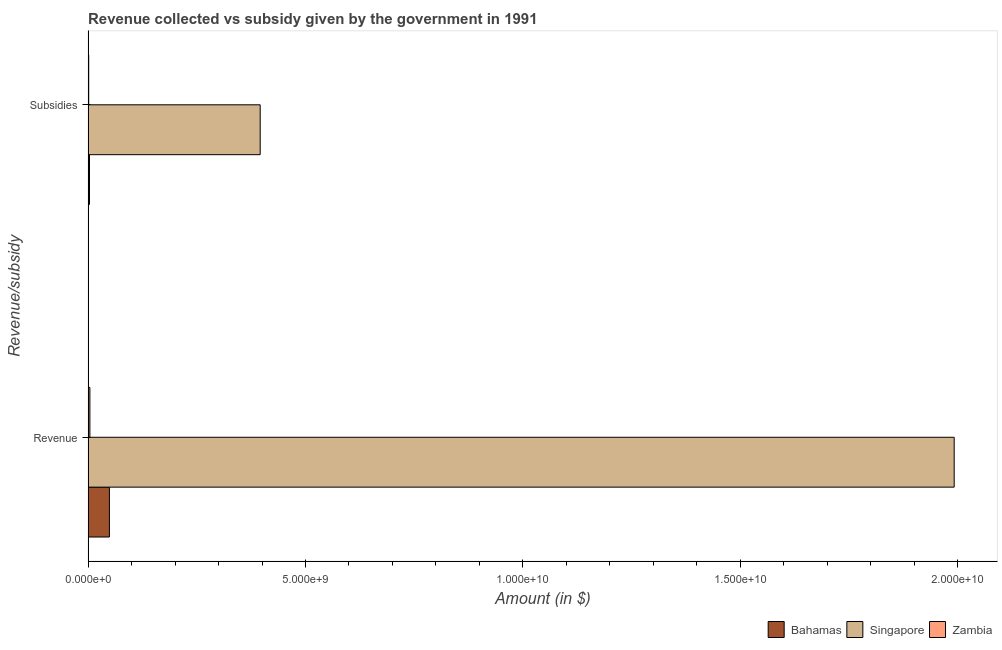How many different coloured bars are there?
Provide a short and direct response. 3. How many groups of bars are there?
Keep it short and to the point. 2. Are the number of bars on each tick of the Y-axis equal?
Your response must be concise. Yes. How many bars are there on the 1st tick from the bottom?
Give a very brief answer. 3. What is the label of the 2nd group of bars from the top?
Give a very brief answer. Revenue. What is the amount of subsidies given in Zambia?
Make the answer very short. 1.42e+07. Across all countries, what is the maximum amount of revenue collected?
Offer a terse response. 1.99e+1. Across all countries, what is the minimum amount of revenue collected?
Ensure brevity in your answer.  4.15e+07. In which country was the amount of subsidies given maximum?
Your response must be concise. Singapore. In which country was the amount of revenue collected minimum?
Keep it short and to the point. Zambia. What is the total amount of revenue collected in the graph?
Provide a succinct answer. 2.05e+1. What is the difference between the amount of subsidies given in Zambia and that in Singapore?
Provide a short and direct response. -3.94e+09. What is the difference between the amount of subsidies given in Singapore and the amount of revenue collected in Zambia?
Your answer should be compact. 3.92e+09. What is the average amount of subsidies given per country?
Give a very brief answer. 1.33e+09. What is the difference between the amount of revenue collected and amount of subsidies given in Bahamas?
Provide a succinct answer. 4.59e+08. In how many countries, is the amount of revenue collected greater than 8000000000 $?
Provide a succinct answer. 1. What is the ratio of the amount of subsidies given in Bahamas to that in Singapore?
Your response must be concise. 0.01. Is the amount of subsidies given in Bahamas less than that in Zambia?
Provide a succinct answer. No. In how many countries, is the amount of subsidies given greater than the average amount of subsidies given taken over all countries?
Offer a very short reply. 1. What does the 1st bar from the top in Revenue represents?
Offer a terse response. Zambia. What does the 3rd bar from the bottom in Subsidies represents?
Keep it short and to the point. Zambia. How many bars are there?
Offer a very short reply. 6. Are all the bars in the graph horizontal?
Make the answer very short. Yes. What is the difference between two consecutive major ticks on the X-axis?
Provide a short and direct response. 5.00e+09. Does the graph contain any zero values?
Make the answer very short. No. Where does the legend appear in the graph?
Offer a terse response. Bottom right. How are the legend labels stacked?
Make the answer very short. Horizontal. What is the title of the graph?
Provide a succinct answer. Revenue collected vs subsidy given by the government in 1991. Does "South Africa" appear as one of the legend labels in the graph?
Ensure brevity in your answer.  No. What is the label or title of the X-axis?
Offer a very short reply. Amount (in $). What is the label or title of the Y-axis?
Provide a succinct answer. Revenue/subsidy. What is the Amount (in $) of Bahamas in Revenue?
Your answer should be very brief. 4.91e+08. What is the Amount (in $) in Singapore in Revenue?
Provide a succinct answer. 1.99e+1. What is the Amount (in $) of Zambia in Revenue?
Give a very brief answer. 4.15e+07. What is the Amount (in $) of Bahamas in Subsidies?
Ensure brevity in your answer.  3.20e+07. What is the Amount (in $) of Singapore in Subsidies?
Your answer should be compact. 3.96e+09. What is the Amount (in $) of Zambia in Subsidies?
Offer a very short reply. 1.42e+07. Across all Revenue/subsidy, what is the maximum Amount (in $) of Bahamas?
Offer a terse response. 4.91e+08. Across all Revenue/subsidy, what is the maximum Amount (in $) of Singapore?
Your answer should be compact. 1.99e+1. Across all Revenue/subsidy, what is the maximum Amount (in $) of Zambia?
Give a very brief answer. 4.15e+07. Across all Revenue/subsidy, what is the minimum Amount (in $) of Bahamas?
Offer a very short reply. 3.20e+07. Across all Revenue/subsidy, what is the minimum Amount (in $) of Singapore?
Keep it short and to the point. 3.96e+09. Across all Revenue/subsidy, what is the minimum Amount (in $) in Zambia?
Keep it short and to the point. 1.42e+07. What is the total Amount (in $) in Bahamas in the graph?
Provide a succinct answer. 5.23e+08. What is the total Amount (in $) in Singapore in the graph?
Keep it short and to the point. 2.39e+1. What is the total Amount (in $) of Zambia in the graph?
Provide a succinct answer. 5.58e+07. What is the difference between the Amount (in $) of Bahamas in Revenue and that in Subsidies?
Offer a very short reply. 4.59e+08. What is the difference between the Amount (in $) of Singapore in Revenue and that in Subsidies?
Provide a succinct answer. 1.60e+1. What is the difference between the Amount (in $) of Zambia in Revenue and that in Subsidies?
Your answer should be compact. 2.73e+07. What is the difference between the Amount (in $) of Bahamas in Revenue and the Amount (in $) of Singapore in Subsidies?
Your response must be concise. -3.47e+09. What is the difference between the Amount (in $) of Bahamas in Revenue and the Amount (in $) of Zambia in Subsidies?
Offer a terse response. 4.76e+08. What is the difference between the Amount (in $) of Singapore in Revenue and the Amount (in $) of Zambia in Subsidies?
Your response must be concise. 1.99e+1. What is the average Amount (in $) of Bahamas per Revenue/subsidy?
Make the answer very short. 2.61e+08. What is the average Amount (in $) of Singapore per Revenue/subsidy?
Make the answer very short. 1.19e+1. What is the average Amount (in $) of Zambia per Revenue/subsidy?
Your answer should be very brief. 2.79e+07. What is the difference between the Amount (in $) in Bahamas and Amount (in $) in Singapore in Revenue?
Make the answer very short. -1.94e+1. What is the difference between the Amount (in $) in Bahamas and Amount (in $) in Zambia in Revenue?
Your answer should be very brief. 4.49e+08. What is the difference between the Amount (in $) of Singapore and Amount (in $) of Zambia in Revenue?
Offer a very short reply. 1.99e+1. What is the difference between the Amount (in $) of Bahamas and Amount (in $) of Singapore in Subsidies?
Your response must be concise. -3.93e+09. What is the difference between the Amount (in $) in Bahamas and Amount (in $) in Zambia in Subsidies?
Your answer should be very brief. 1.78e+07. What is the difference between the Amount (in $) in Singapore and Amount (in $) in Zambia in Subsidies?
Your answer should be very brief. 3.94e+09. What is the ratio of the Amount (in $) in Bahamas in Revenue to that in Subsidies?
Your answer should be very brief. 15.33. What is the ratio of the Amount (in $) in Singapore in Revenue to that in Subsidies?
Give a very brief answer. 5.03. What is the ratio of the Amount (in $) in Zambia in Revenue to that in Subsidies?
Keep it short and to the point. 2.91. What is the difference between the highest and the second highest Amount (in $) of Bahamas?
Make the answer very short. 4.59e+08. What is the difference between the highest and the second highest Amount (in $) of Singapore?
Make the answer very short. 1.60e+1. What is the difference between the highest and the second highest Amount (in $) of Zambia?
Offer a terse response. 2.73e+07. What is the difference between the highest and the lowest Amount (in $) of Bahamas?
Provide a short and direct response. 4.59e+08. What is the difference between the highest and the lowest Amount (in $) in Singapore?
Give a very brief answer. 1.60e+1. What is the difference between the highest and the lowest Amount (in $) of Zambia?
Your response must be concise. 2.73e+07. 